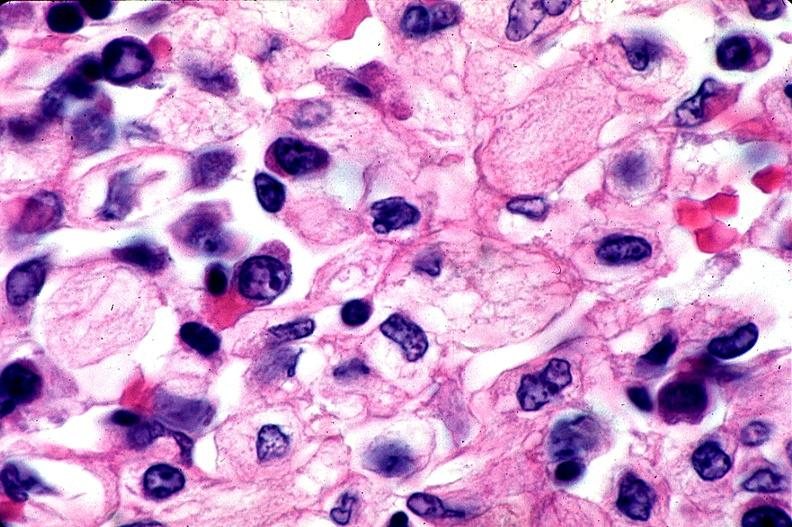does this image show gaucher disease?
Answer the question using a single word or phrase. Yes 